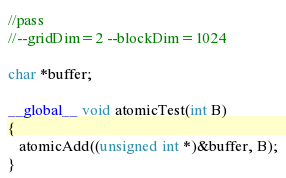<code> <loc_0><loc_0><loc_500><loc_500><_Cuda_>//pass
//--gridDim=2 --blockDim=1024

char *buffer;

__global__ void atomicTest(int B)
{
   atomicAdd((unsigned int *)&buffer, B);
}

</code> 